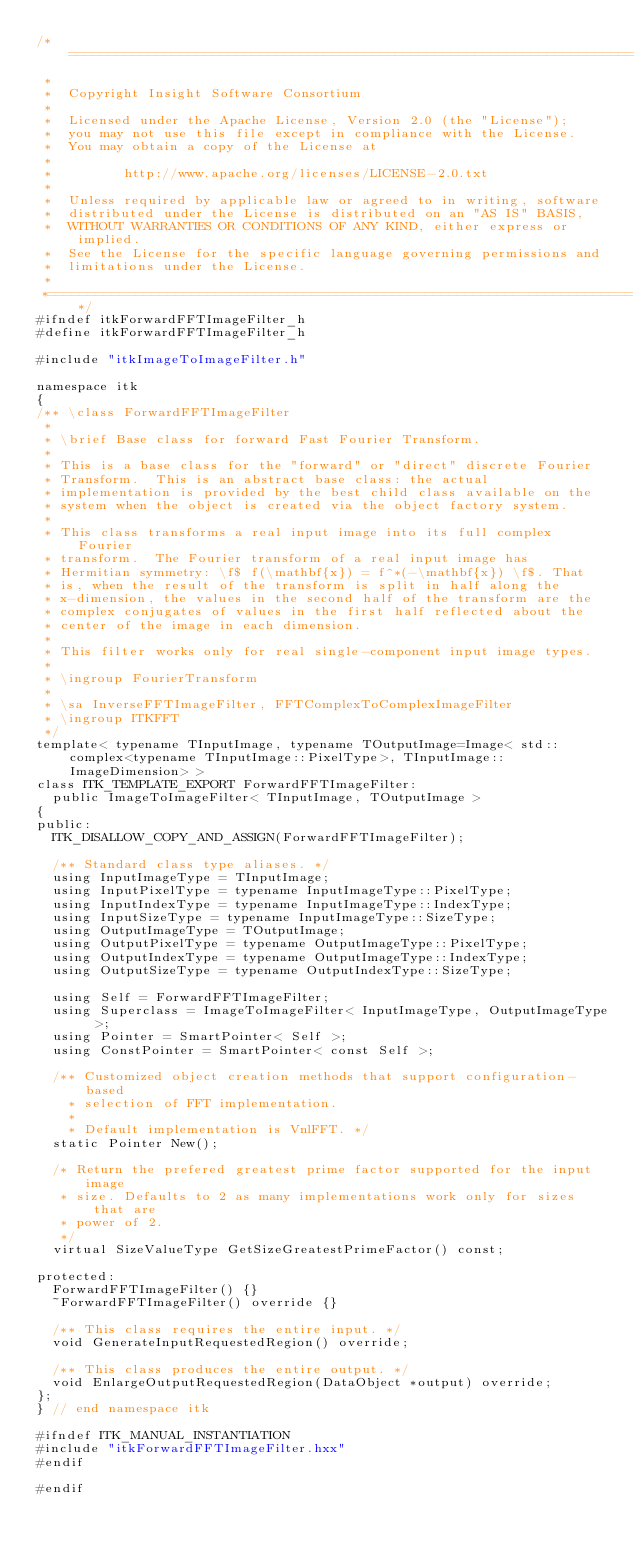<code> <loc_0><loc_0><loc_500><loc_500><_C_>/*=========================================================================
 *
 *  Copyright Insight Software Consortium
 *
 *  Licensed under the Apache License, Version 2.0 (the "License");
 *  you may not use this file except in compliance with the License.
 *  You may obtain a copy of the License at
 *
 *         http://www.apache.org/licenses/LICENSE-2.0.txt
 *
 *  Unless required by applicable law or agreed to in writing, software
 *  distributed under the License is distributed on an "AS IS" BASIS,
 *  WITHOUT WARRANTIES OR CONDITIONS OF ANY KIND, either express or implied.
 *  See the License for the specific language governing permissions and
 *  limitations under the License.
 *
 *=========================================================================*/
#ifndef itkForwardFFTImageFilter_h
#define itkForwardFFTImageFilter_h

#include "itkImageToImageFilter.h"

namespace itk
{
/** \class ForwardFFTImageFilter
 *
 * \brief Base class for forward Fast Fourier Transform.
 *
 * This is a base class for the "forward" or "direct" discrete Fourier
 * Transform.  This is an abstract base class: the actual
 * implementation is provided by the best child class available on the
 * system when the object is created via the object factory system.
 *
 * This class transforms a real input image into its full complex Fourier
 * transform.  The Fourier transform of a real input image has
 * Hermitian symmetry: \f$ f(\mathbf{x}) = f^*(-\mathbf{x}) \f$. That
 * is, when the result of the transform is split in half along the
 * x-dimension, the values in the second half of the transform are the
 * complex conjugates of values in the first half reflected about the
 * center of the image in each dimension.
 *
 * This filter works only for real single-component input image types.
 *
 * \ingroup FourierTransform
 *
 * \sa InverseFFTImageFilter, FFTComplexToComplexImageFilter
 * \ingroup ITKFFT
 */
template< typename TInputImage, typename TOutputImage=Image< std::complex<typename TInputImage::PixelType>, TInputImage::ImageDimension> >
class ITK_TEMPLATE_EXPORT ForwardFFTImageFilter:
  public ImageToImageFilter< TInputImage, TOutputImage >
{
public:
  ITK_DISALLOW_COPY_AND_ASSIGN(ForwardFFTImageFilter);

  /** Standard class type aliases. */
  using InputImageType = TInputImage;
  using InputPixelType = typename InputImageType::PixelType;
  using InputIndexType = typename InputImageType::IndexType;
  using InputSizeType = typename InputImageType::SizeType;
  using OutputImageType = TOutputImage;
  using OutputPixelType = typename OutputImageType::PixelType;
  using OutputIndexType = typename OutputImageType::IndexType;
  using OutputSizeType = typename OutputIndexType::SizeType;

  using Self = ForwardFFTImageFilter;
  using Superclass = ImageToImageFilter< InputImageType, OutputImageType >;
  using Pointer = SmartPointer< Self >;
  using ConstPointer = SmartPointer< const Self >;

  /** Customized object creation methods that support configuration-based
    * selection of FFT implementation.
    *
    * Default implementation is VnlFFT. */
  static Pointer New();

  /* Return the prefered greatest prime factor supported for the input image
   * size. Defaults to 2 as many implementations work only for sizes that are
   * power of 2.
   */
  virtual SizeValueType GetSizeGreatestPrimeFactor() const;

protected:
  ForwardFFTImageFilter() {}
  ~ForwardFFTImageFilter() override {}

  /** This class requires the entire input. */
  void GenerateInputRequestedRegion() override;

  /** This class produces the entire output. */
  void EnlargeOutputRequestedRegion(DataObject *output) override;
};
} // end namespace itk

#ifndef ITK_MANUAL_INSTANTIATION
#include "itkForwardFFTImageFilter.hxx"
#endif

#endif
</code> 